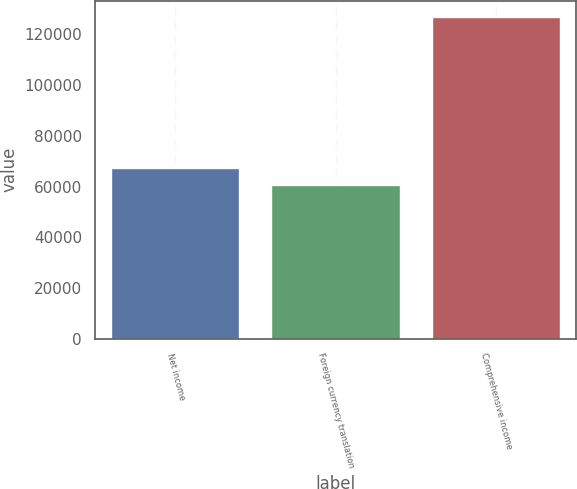Convert chart to OTSL. <chart><loc_0><loc_0><loc_500><loc_500><bar_chart><fcel>Net income<fcel>Foreign currency translation<fcel>Comprehensive income<nl><fcel>67249.2<fcel>60619<fcel>126921<nl></chart> 